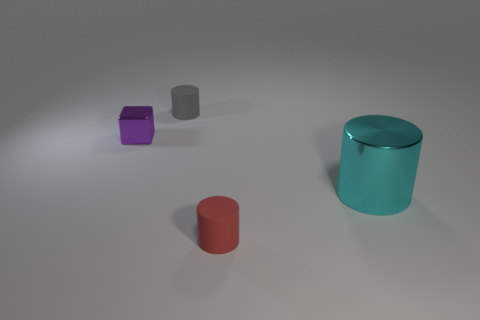What number of big cylinders are to the right of the tiny cylinder that is in front of the metallic object that is left of the gray rubber object?
Your response must be concise. 1. There is a matte cylinder that is in front of the gray thing; what is its color?
Your response must be concise. Red. The thing that is to the left of the small cylinder that is behind the big cyan thing is what shape?
Offer a terse response. Cube. Does the cube have the same color as the metallic cylinder?
Offer a very short reply. No. How many balls are small purple shiny things or gray matte objects?
Your answer should be compact. 0. What is the cylinder that is left of the large cylinder and in front of the small cube made of?
Your response must be concise. Rubber. There is a cyan metallic object; what number of cyan things are to the right of it?
Give a very brief answer. 0. Do the cylinder to the left of the small red cylinder and the object in front of the big shiny cylinder have the same material?
Make the answer very short. Yes. How many objects are shiny things that are right of the tiny purple object or small gray rubber things?
Offer a terse response. 2. Are there fewer tiny shiny blocks to the left of the tiny purple object than gray rubber objects on the right side of the red object?
Ensure brevity in your answer.  No. 